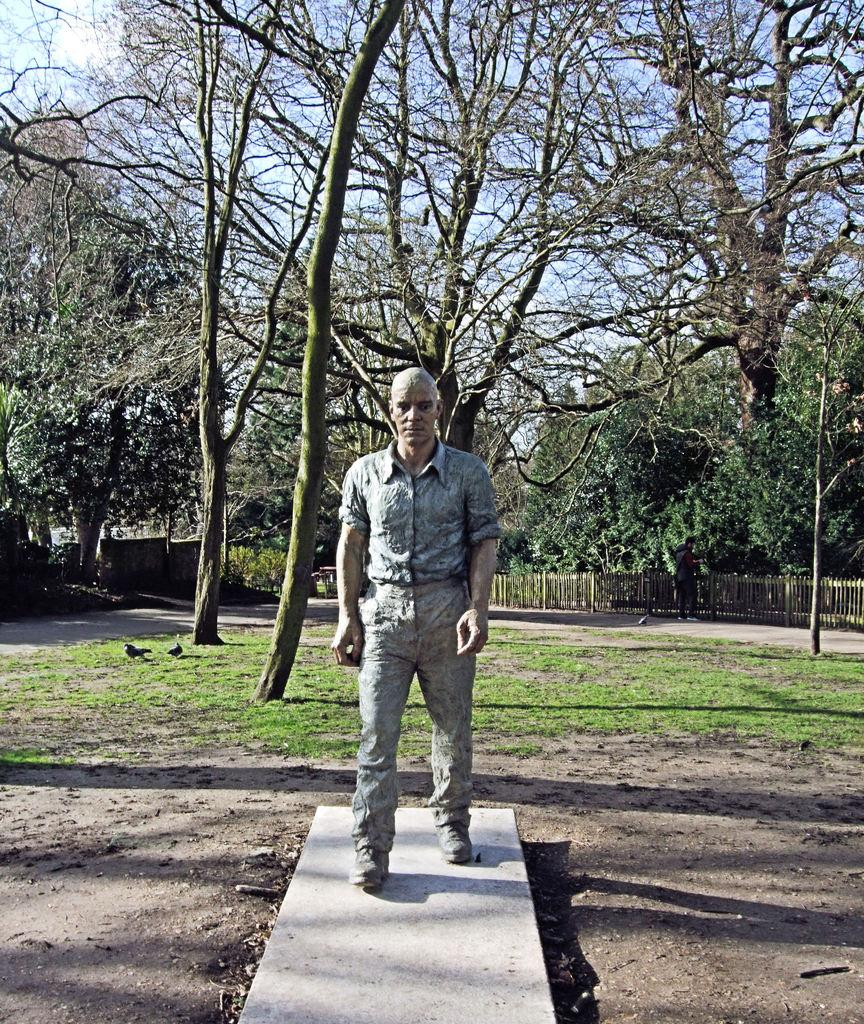What is the main subject of the image? There is a sculpture of a man in the image. Where is the sculpture located? The sculpture is on a surface. What can be seen in the background of the image? There is grass, trees, and the sky partially visible through the trees in the background of the image. What type of cake is being served at the art exhibit in the image? There is no cake or art exhibit present in the image; it features a sculpture of a man on a surface with a grassy and tree-filled background. 